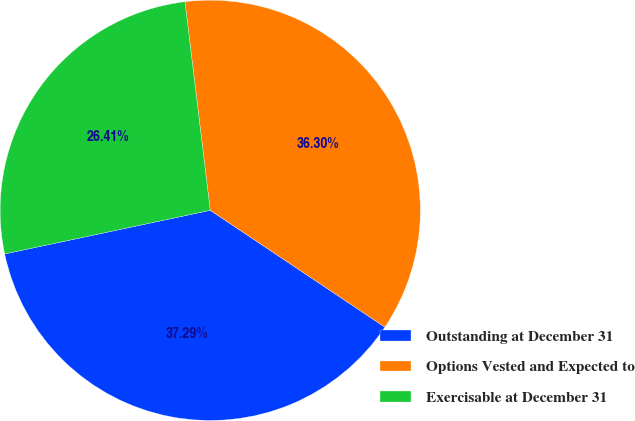Convert chart. <chart><loc_0><loc_0><loc_500><loc_500><pie_chart><fcel>Outstanding at December 31<fcel>Options Vested and Expected to<fcel>Exercisable at December 31<nl><fcel>37.29%<fcel>36.3%<fcel>26.41%<nl></chart> 